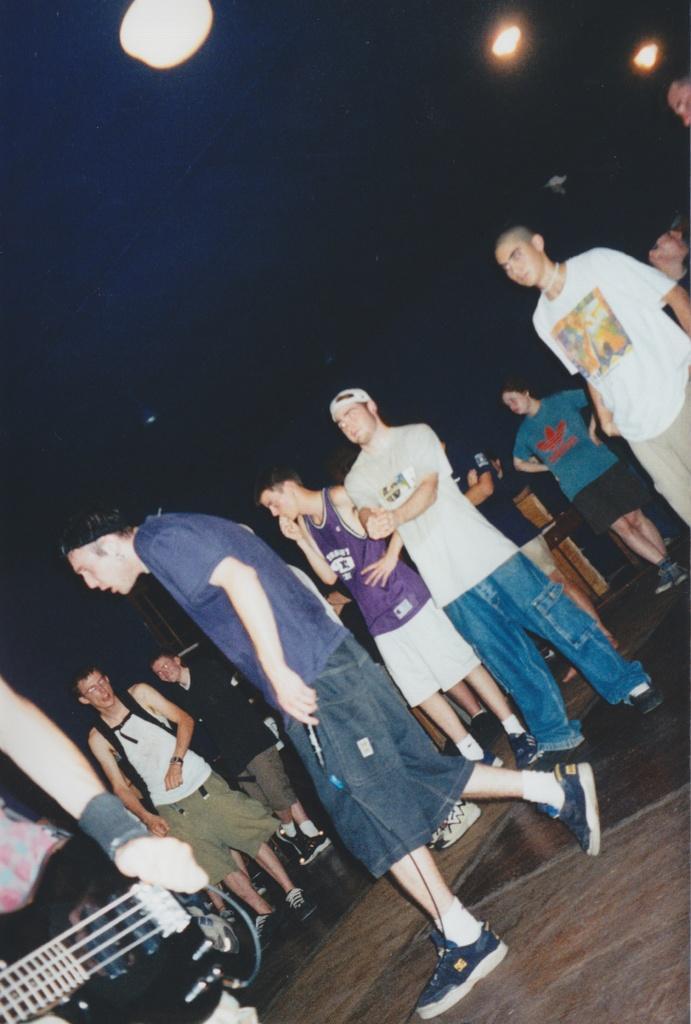How would you summarize this image in a sentence or two? This is the picture taken in a room, there are group of people standing on a floor. Background of this people is black color and three lights. 